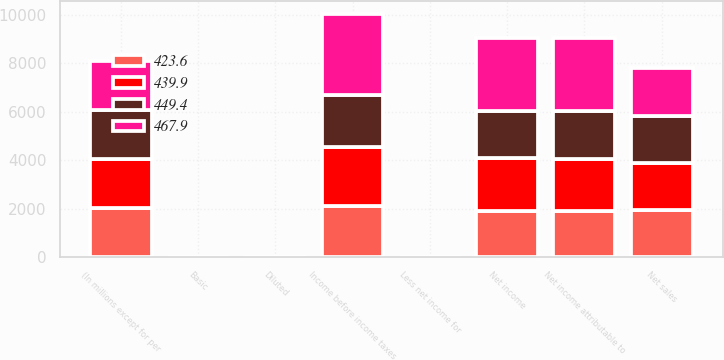Convert chart to OTSL. <chart><loc_0><loc_0><loc_500><loc_500><stacked_bar_chart><ecel><fcel>(In millions except for per<fcel>Net sales<fcel>Income before income taxes<fcel>Net income<fcel>Less net income for<fcel>Net income attributable to<fcel>Diluted<fcel>Basic<nl><fcel>439.9<fcel>2018<fcel>1945.5<fcel>2424<fcel>2146<fcel>1<fcel>2145<fcel>4.91<fcel>4.93<nl><fcel>467.9<fcel>2017<fcel>1945.5<fcel>3368<fcel>2986<fcel>1<fcel>2985<fcel>6.68<fcel>6.71<nl><fcel>423.6<fcel>2016<fcel>1945.5<fcel>2118<fcel>1919<fcel>3<fcel>1916<fcel>4.2<fcel>4.21<nl><fcel>449.4<fcel>2015<fcel>1945.5<fcel>2133<fcel>1974<fcel>2<fcel>1972<fcel>4.22<fcel>4.23<nl></chart> 